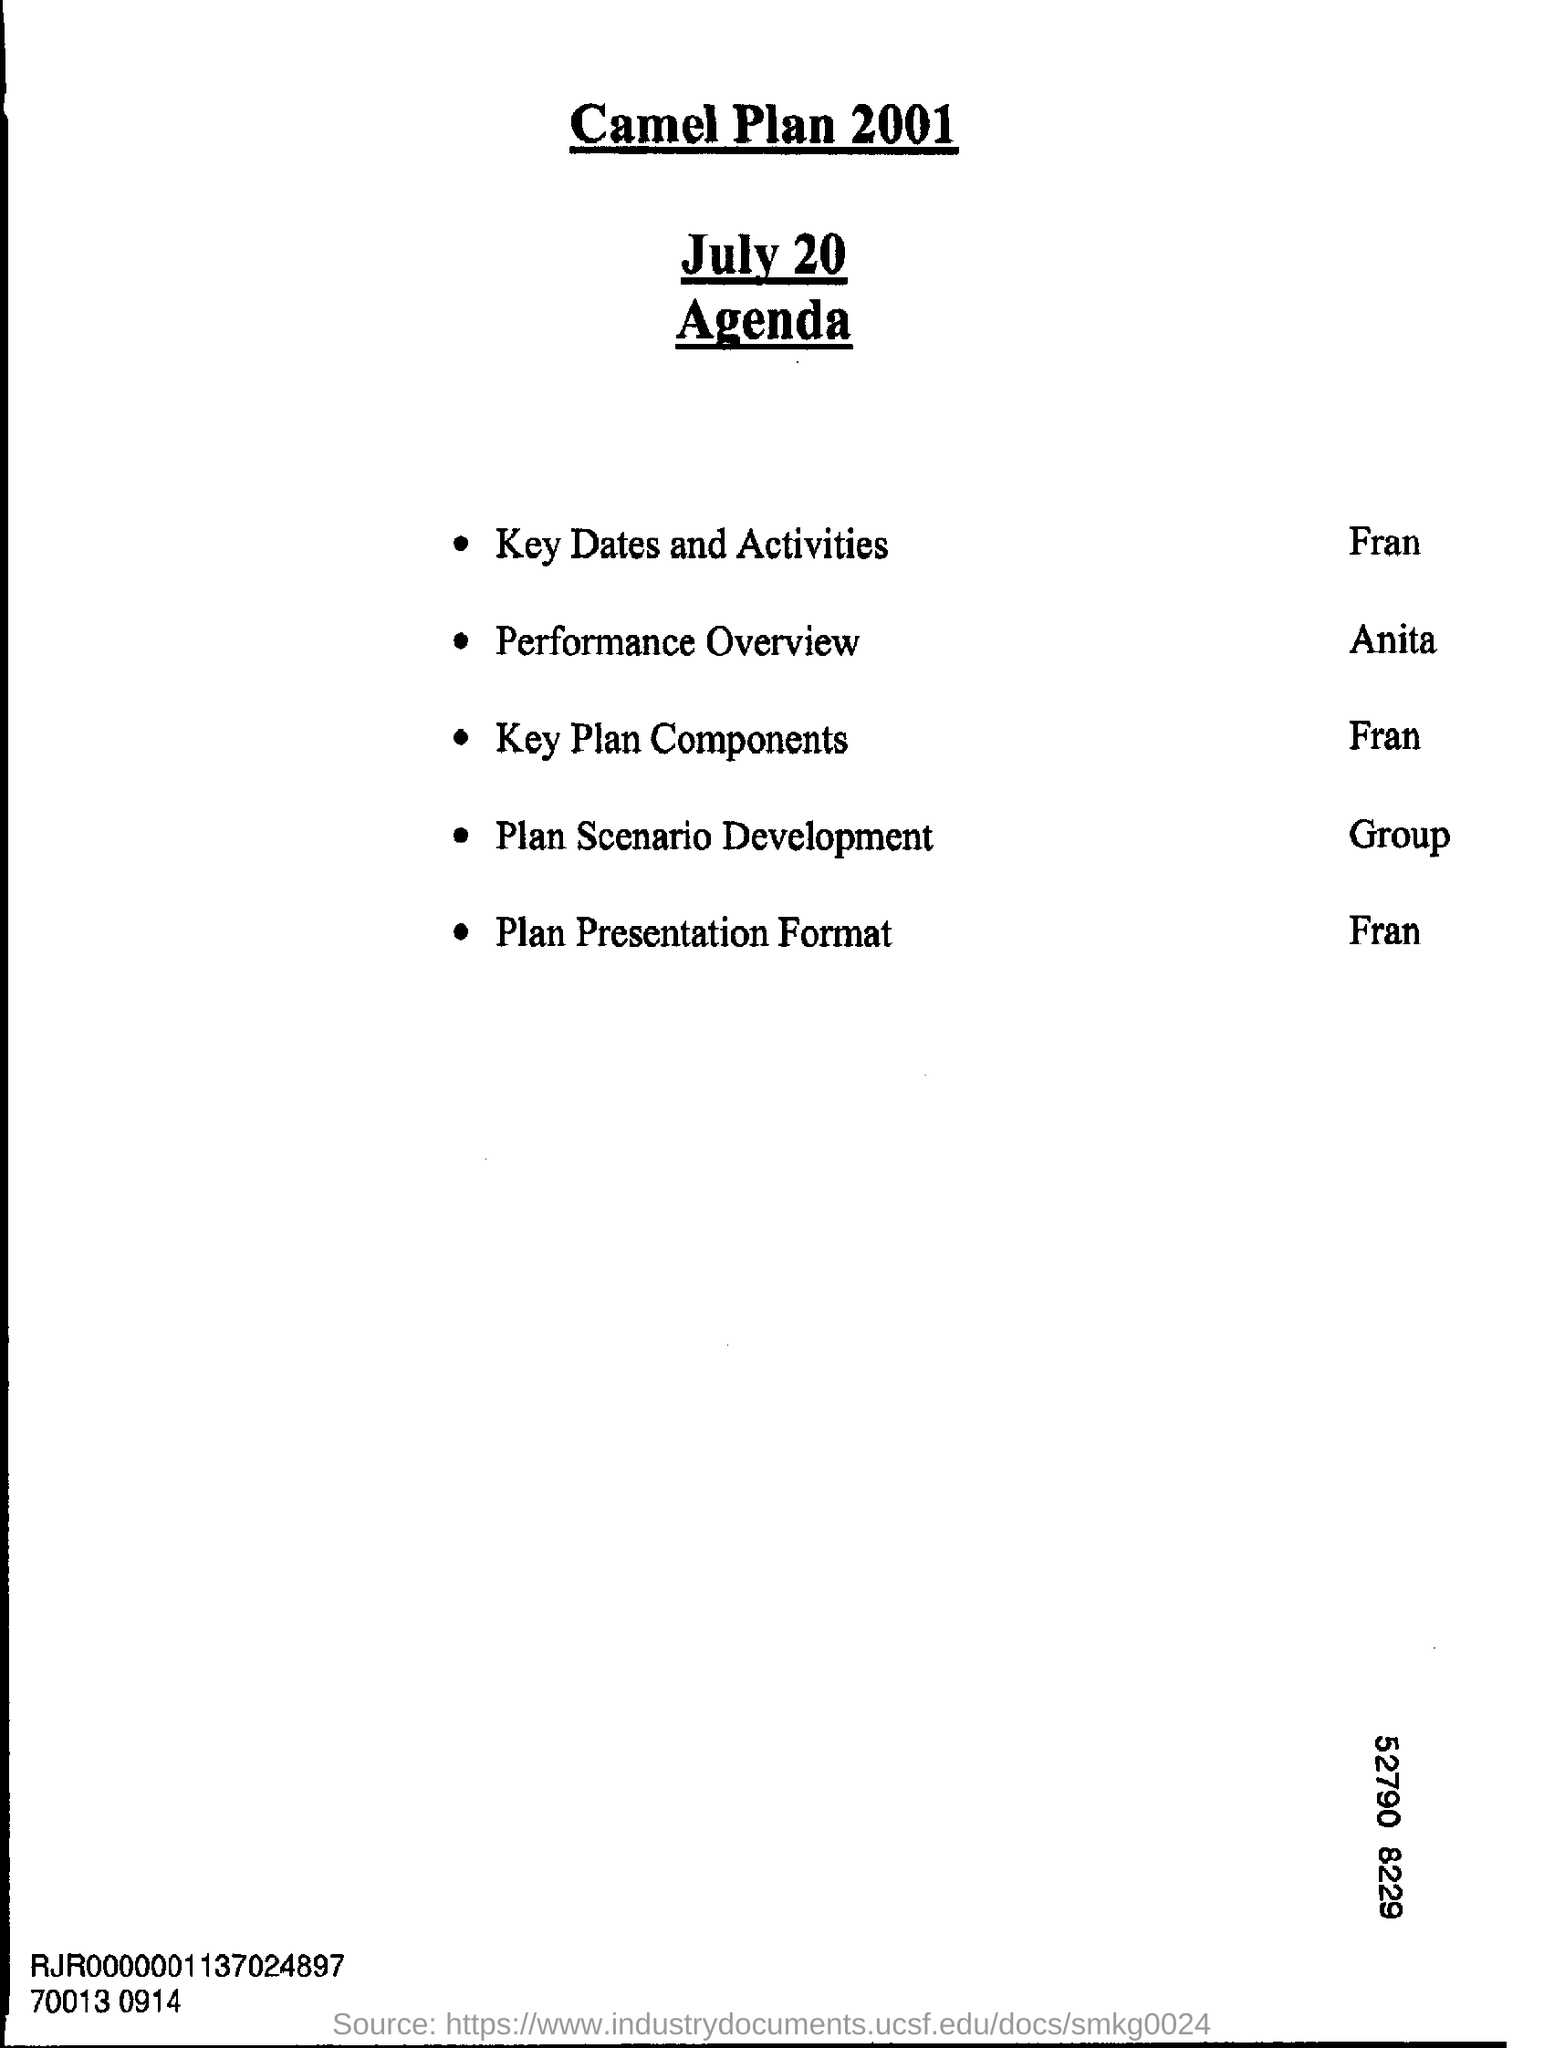Mention a couple of crucial points in this snapshot. The title of the agenda is the Camel Plan 2001. 